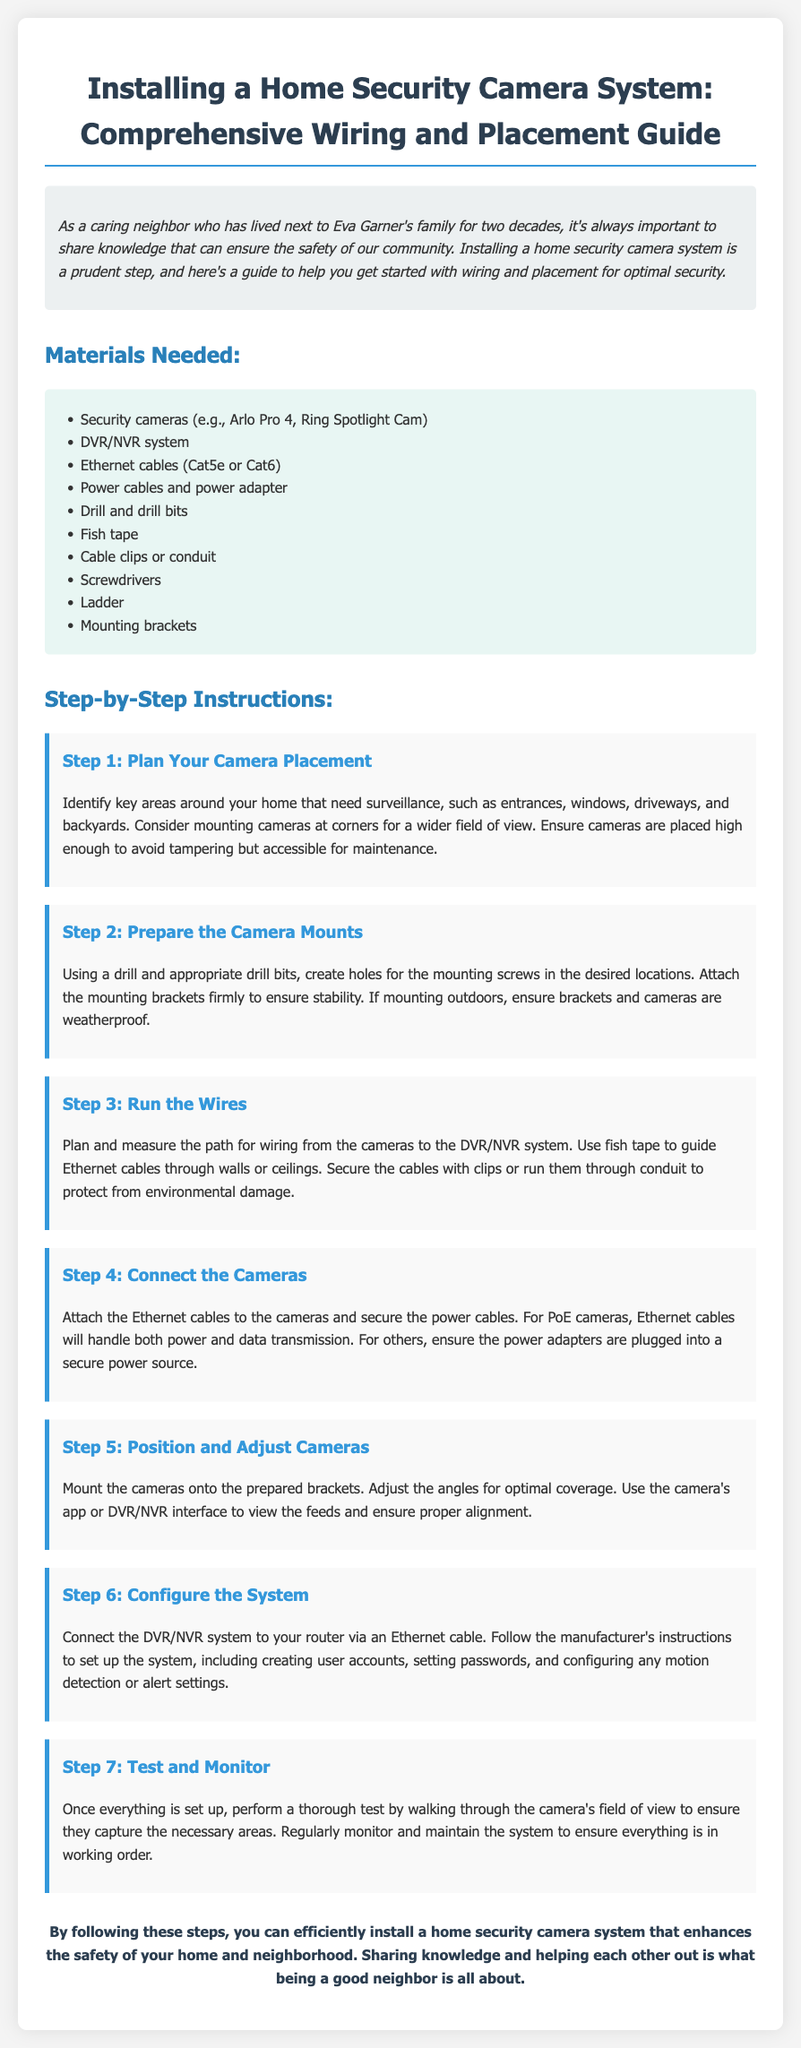what is the title of the guide? The title of the guide is stated at the top of the document in a prominent header format.
Answer: Installing a Home Security Camera System: Comprehensive Wiring and Placement Guide how many steps are in the installation process? The total steps are listed under the "Step-by-Step Instructions" section and counted.
Answer: 7 what is the first step in the installation process? The first step is specifically outlined in the document.
Answer: Plan Your Camera Placement what type of Ethernet cables are mentioned? The document specifies which types of Ethernet cables are needed.
Answer: Cat5e or Cat6 what is necessary before mounting the security cameras? The guide outlines actions to complete before mounting, specifically in the steps provided.
Answer: Prepare the Camera Mounts how should cables be secured during installation? The document provides specific methods for securing cables to ensure safety and organization.
Answer: Cable clips or conduit what should you do after testing the camera setup? The document concludes this process with a recommendation regarding system maintenance.
Answer: Monitor and maintain the system 